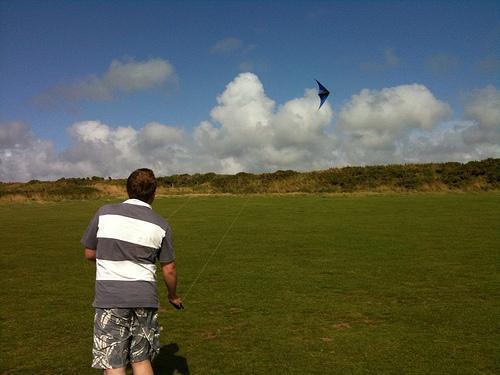How many boys are there?
Give a very brief answer. 1. 